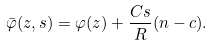Convert formula to latex. <formula><loc_0><loc_0><loc_500><loc_500>\bar { \varphi } ( z , s ) = \varphi ( z ) + \frac { C s } { R } ( n - c ) .</formula> 